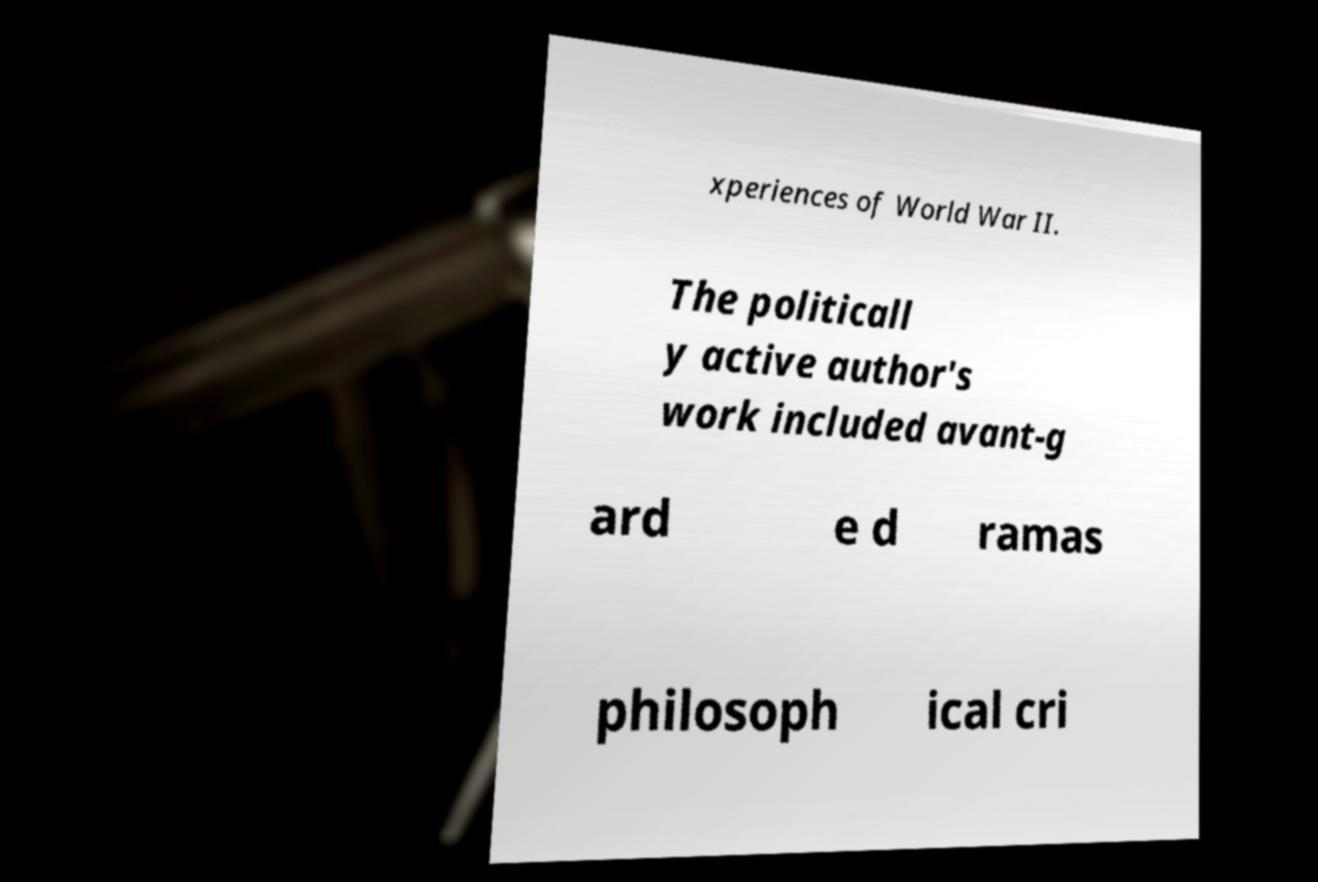Could you assist in decoding the text presented in this image and type it out clearly? xperiences of World War II. The politicall y active author's work included avant-g ard e d ramas philosoph ical cri 